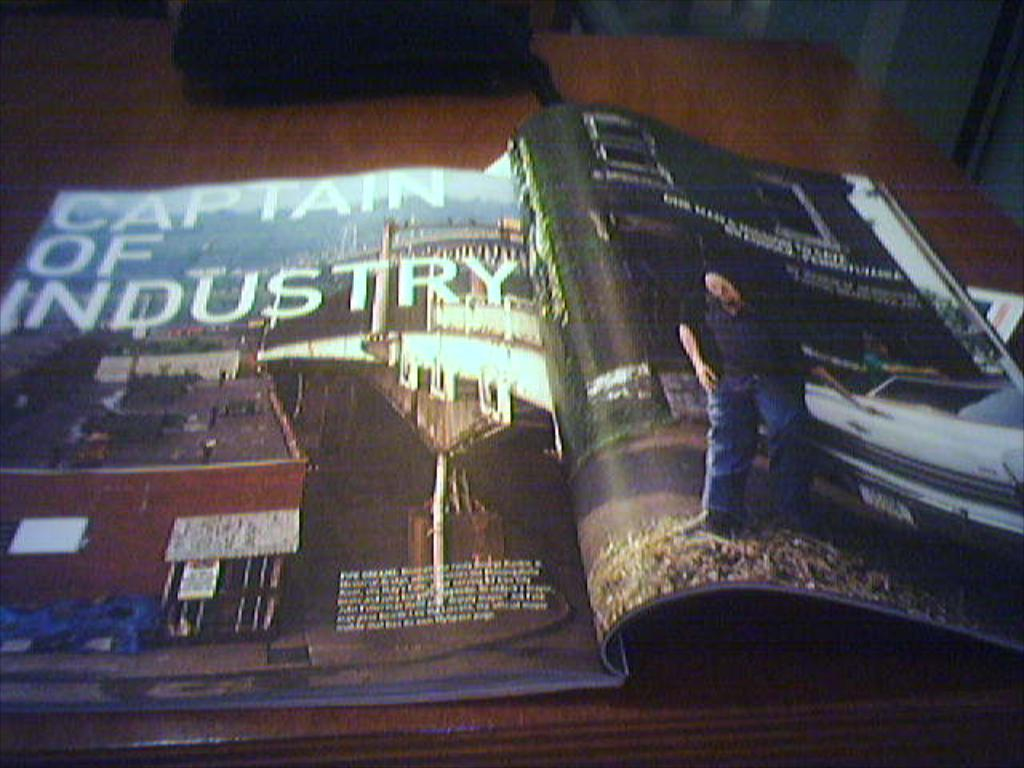Provide a one-sentence caption for the provided image. A magazine is opened and shows text that reads CAPTAIN OF INDUSTRY. 